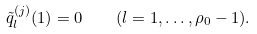<formula> <loc_0><loc_0><loc_500><loc_500>\tilde { q } ^ { ( j ) } _ { l } ( 1 ) = 0 \quad ( l = 1 , \dots , \rho _ { 0 } - 1 ) .</formula> 